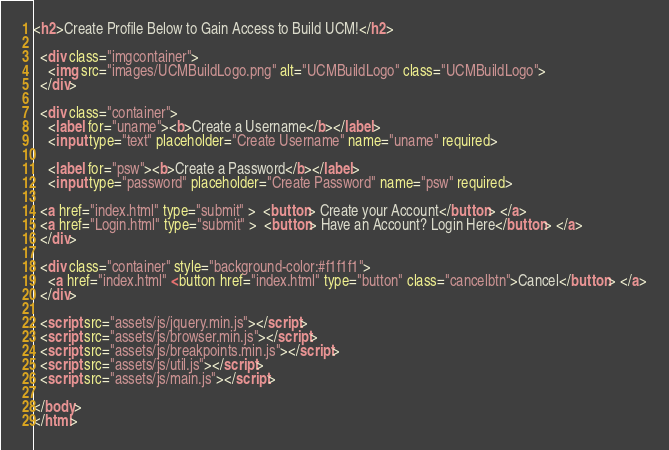Convert code to text. <code><loc_0><loc_0><loc_500><loc_500><_HTML_><h2>Create Profile Below to Gain Access to Build UCM!</h2>

  <div class="imgcontainer">
    <img src="images/UCMBuildLogo.png" alt="UCMBuildLogo" class="UCMBuildLogo">
  </div>

  <div class="container">
    <label for="uname"><b>Create a Username</b></label>
    <input type="text" placeholder="Create Username" name="uname" required>

    <label for="psw"><b>Create a Password</b></label>
    <input type="password" placeholder="Create Password" name="psw" required>

  <a href="index.html" type="submit" >  <button> Create your Account</button> </a>
  <a href="Login.html" type="submit" >  <button> Have an Account? Login Here</button> </a>
  </div>

  <div class="container" style="background-color:#f1f1f1">
    <a href="index.html" <button href="index.html" type="button" class="cancelbtn">Cancel</button> </a>
  </div>

  <script src="assets/js/jquery.min.js"></script>
  <script src="assets/js/browser.min.js"></script>
  <script src="assets/js/breakpoints.min.js"></script>
  <script src="assets/js/util.js"></script>
  <script src="assets/js/main.js"></script>

</body>
</html>
</code> 